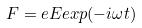<formula> <loc_0><loc_0><loc_500><loc_500>F = e E e x p ( - i \omega t )</formula> 